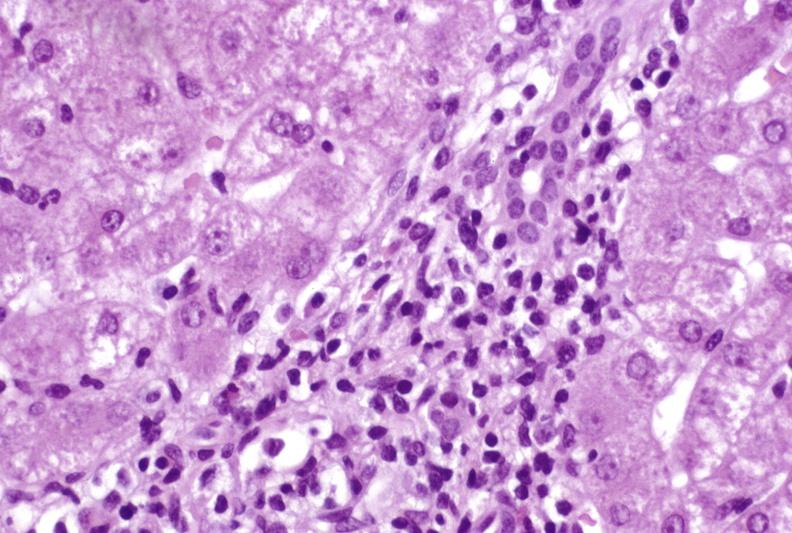s liver present?
Answer the question using a single word or phrase. Yes 